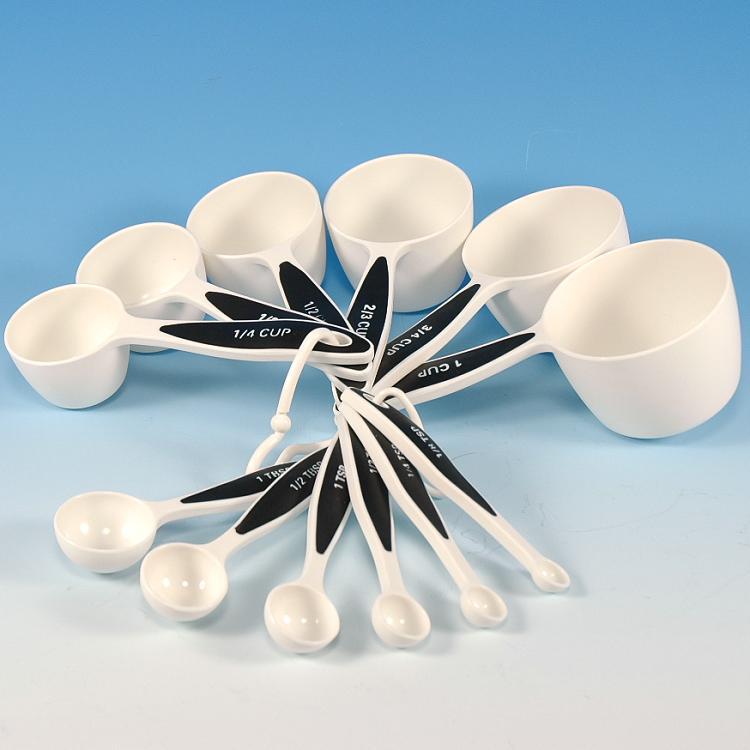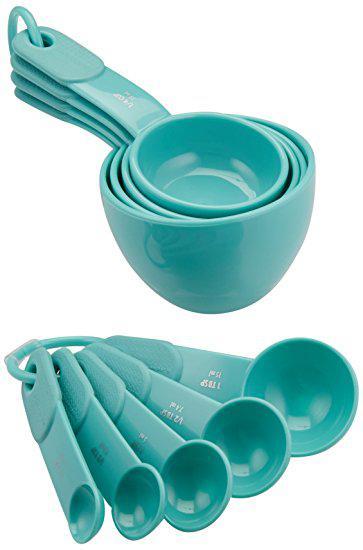The first image is the image on the left, the second image is the image on the right. For the images displayed, is the sentence "An image features measuring utensils with blue coloring." factually correct? Answer yes or no. Yes. 